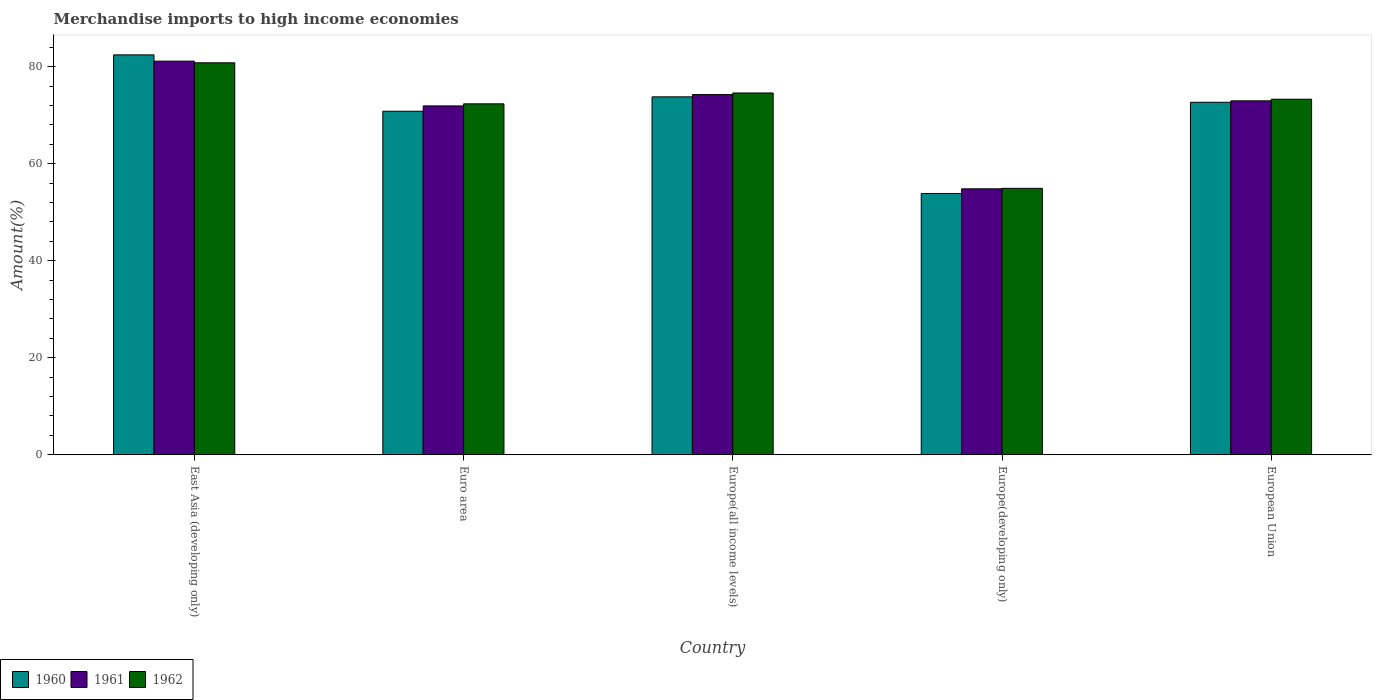How many different coloured bars are there?
Offer a very short reply. 3. How many groups of bars are there?
Provide a short and direct response. 5. Are the number of bars per tick equal to the number of legend labels?
Give a very brief answer. Yes. Are the number of bars on each tick of the X-axis equal?
Ensure brevity in your answer.  Yes. What is the label of the 3rd group of bars from the left?
Give a very brief answer. Europe(all income levels). In how many cases, is the number of bars for a given country not equal to the number of legend labels?
Give a very brief answer. 0. What is the percentage of amount earned from merchandise imports in 1962 in Europe(all income levels)?
Your response must be concise. 74.58. Across all countries, what is the maximum percentage of amount earned from merchandise imports in 1960?
Provide a short and direct response. 82.44. Across all countries, what is the minimum percentage of amount earned from merchandise imports in 1961?
Your answer should be very brief. 54.82. In which country was the percentage of amount earned from merchandise imports in 1960 maximum?
Offer a very short reply. East Asia (developing only). In which country was the percentage of amount earned from merchandise imports in 1960 minimum?
Your answer should be very brief. Europe(developing only). What is the total percentage of amount earned from merchandise imports in 1961 in the graph?
Make the answer very short. 355.09. What is the difference between the percentage of amount earned from merchandise imports in 1961 in Europe(developing only) and that in European Union?
Provide a short and direct response. -18.14. What is the difference between the percentage of amount earned from merchandise imports in 1961 in Europe(all income levels) and the percentage of amount earned from merchandise imports in 1962 in East Asia (developing only)?
Your answer should be very brief. -6.55. What is the average percentage of amount earned from merchandise imports in 1960 per country?
Your response must be concise. 70.71. What is the difference between the percentage of amount earned from merchandise imports of/in 1961 and percentage of amount earned from merchandise imports of/in 1960 in East Asia (developing only)?
Provide a succinct answer. -1.29. What is the ratio of the percentage of amount earned from merchandise imports in 1962 in Europe(all income levels) to that in European Union?
Your answer should be compact. 1.02. Is the difference between the percentage of amount earned from merchandise imports in 1961 in East Asia (developing only) and European Union greater than the difference between the percentage of amount earned from merchandise imports in 1960 in East Asia (developing only) and European Union?
Keep it short and to the point. No. What is the difference between the highest and the second highest percentage of amount earned from merchandise imports in 1962?
Offer a very short reply. 7.51. What is the difference between the highest and the lowest percentage of amount earned from merchandise imports in 1960?
Make the answer very short. 28.57. What does the 1st bar from the right in European Union represents?
Provide a short and direct response. 1962. Are all the bars in the graph horizontal?
Give a very brief answer. No. What is the difference between two consecutive major ticks on the Y-axis?
Your answer should be very brief. 20. Does the graph contain grids?
Keep it short and to the point. No. Where does the legend appear in the graph?
Keep it short and to the point. Bottom left. How many legend labels are there?
Offer a terse response. 3. How are the legend labels stacked?
Offer a terse response. Horizontal. What is the title of the graph?
Provide a succinct answer. Merchandise imports to high income economies. Does "1974" appear as one of the legend labels in the graph?
Your answer should be compact. No. What is the label or title of the Y-axis?
Provide a succinct answer. Amount(%). What is the Amount(%) in 1960 in East Asia (developing only)?
Keep it short and to the point. 82.44. What is the Amount(%) of 1961 in East Asia (developing only)?
Offer a very short reply. 81.14. What is the Amount(%) in 1962 in East Asia (developing only)?
Provide a succinct answer. 80.8. What is the Amount(%) in 1960 in Euro area?
Make the answer very short. 70.81. What is the Amount(%) in 1961 in Euro area?
Your answer should be very brief. 71.91. What is the Amount(%) in 1962 in Euro area?
Your answer should be compact. 72.34. What is the Amount(%) of 1960 in Europe(all income levels)?
Provide a succinct answer. 73.78. What is the Amount(%) in 1961 in Europe(all income levels)?
Your answer should be compact. 74.25. What is the Amount(%) in 1962 in Europe(all income levels)?
Ensure brevity in your answer.  74.58. What is the Amount(%) of 1960 in Europe(developing only)?
Ensure brevity in your answer.  53.86. What is the Amount(%) of 1961 in Europe(developing only)?
Offer a very short reply. 54.82. What is the Amount(%) of 1962 in Europe(developing only)?
Offer a very short reply. 54.93. What is the Amount(%) in 1960 in European Union?
Offer a very short reply. 72.67. What is the Amount(%) of 1961 in European Union?
Provide a succinct answer. 72.96. What is the Amount(%) of 1962 in European Union?
Offer a terse response. 73.29. Across all countries, what is the maximum Amount(%) in 1960?
Ensure brevity in your answer.  82.44. Across all countries, what is the maximum Amount(%) of 1961?
Your answer should be very brief. 81.14. Across all countries, what is the maximum Amount(%) of 1962?
Give a very brief answer. 80.8. Across all countries, what is the minimum Amount(%) of 1960?
Ensure brevity in your answer.  53.86. Across all countries, what is the minimum Amount(%) of 1961?
Your answer should be compact. 54.82. Across all countries, what is the minimum Amount(%) in 1962?
Ensure brevity in your answer.  54.93. What is the total Amount(%) in 1960 in the graph?
Provide a short and direct response. 353.56. What is the total Amount(%) in 1961 in the graph?
Your answer should be compact. 355.09. What is the total Amount(%) in 1962 in the graph?
Provide a succinct answer. 355.94. What is the difference between the Amount(%) in 1960 in East Asia (developing only) and that in Euro area?
Offer a terse response. 11.62. What is the difference between the Amount(%) of 1961 in East Asia (developing only) and that in Euro area?
Your response must be concise. 9.23. What is the difference between the Amount(%) of 1962 in East Asia (developing only) and that in Euro area?
Provide a succinct answer. 8.46. What is the difference between the Amount(%) of 1960 in East Asia (developing only) and that in Europe(all income levels)?
Make the answer very short. 8.65. What is the difference between the Amount(%) in 1961 in East Asia (developing only) and that in Europe(all income levels)?
Give a very brief answer. 6.89. What is the difference between the Amount(%) of 1962 in East Asia (developing only) and that in Europe(all income levels)?
Offer a very short reply. 6.22. What is the difference between the Amount(%) of 1960 in East Asia (developing only) and that in Europe(developing only)?
Offer a terse response. 28.57. What is the difference between the Amount(%) of 1961 in East Asia (developing only) and that in Europe(developing only)?
Ensure brevity in your answer.  26.32. What is the difference between the Amount(%) of 1962 in East Asia (developing only) and that in Europe(developing only)?
Give a very brief answer. 25.88. What is the difference between the Amount(%) of 1960 in East Asia (developing only) and that in European Union?
Make the answer very short. 9.77. What is the difference between the Amount(%) of 1961 in East Asia (developing only) and that in European Union?
Ensure brevity in your answer.  8.18. What is the difference between the Amount(%) in 1962 in East Asia (developing only) and that in European Union?
Provide a short and direct response. 7.51. What is the difference between the Amount(%) of 1960 in Euro area and that in Europe(all income levels)?
Your answer should be compact. -2.97. What is the difference between the Amount(%) of 1961 in Euro area and that in Europe(all income levels)?
Keep it short and to the point. -2.33. What is the difference between the Amount(%) in 1962 in Euro area and that in Europe(all income levels)?
Provide a short and direct response. -2.24. What is the difference between the Amount(%) in 1960 in Euro area and that in Europe(developing only)?
Keep it short and to the point. 16.95. What is the difference between the Amount(%) in 1961 in Euro area and that in Europe(developing only)?
Give a very brief answer. 17.09. What is the difference between the Amount(%) of 1962 in Euro area and that in Europe(developing only)?
Provide a short and direct response. 17.42. What is the difference between the Amount(%) of 1960 in Euro area and that in European Union?
Offer a terse response. -1.85. What is the difference between the Amount(%) in 1961 in Euro area and that in European Union?
Your answer should be very brief. -1.05. What is the difference between the Amount(%) in 1962 in Euro area and that in European Union?
Keep it short and to the point. -0.95. What is the difference between the Amount(%) of 1960 in Europe(all income levels) and that in Europe(developing only)?
Your response must be concise. 19.92. What is the difference between the Amount(%) in 1961 in Europe(all income levels) and that in Europe(developing only)?
Give a very brief answer. 19.42. What is the difference between the Amount(%) of 1962 in Europe(all income levels) and that in Europe(developing only)?
Provide a short and direct response. 19.66. What is the difference between the Amount(%) in 1960 in Europe(all income levels) and that in European Union?
Make the answer very short. 1.12. What is the difference between the Amount(%) of 1961 in Europe(all income levels) and that in European Union?
Give a very brief answer. 1.29. What is the difference between the Amount(%) in 1962 in Europe(all income levels) and that in European Union?
Your answer should be compact. 1.29. What is the difference between the Amount(%) of 1960 in Europe(developing only) and that in European Union?
Keep it short and to the point. -18.8. What is the difference between the Amount(%) of 1961 in Europe(developing only) and that in European Union?
Give a very brief answer. -18.14. What is the difference between the Amount(%) of 1962 in Europe(developing only) and that in European Union?
Provide a short and direct response. -18.37. What is the difference between the Amount(%) in 1960 in East Asia (developing only) and the Amount(%) in 1961 in Euro area?
Ensure brevity in your answer.  10.52. What is the difference between the Amount(%) of 1960 in East Asia (developing only) and the Amount(%) of 1962 in Euro area?
Provide a succinct answer. 10.09. What is the difference between the Amount(%) of 1961 in East Asia (developing only) and the Amount(%) of 1962 in Euro area?
Your response must be concise. 8.8. What is the difference between the Amount(%) of 1960 in East Asia (developing only) and the Amount(%) of 1961 in Europe(all income levels)?
Ensure brevity in your answer.  8.19. What is the difference between the Amount(%) of 1960 in East Asia (developing only) and the Amount(%) of 1962 in Europe(all income levels)?
Provide a succinct answer. 7.85. What is the difference between the Amount(%) of 1961 in East Asia (developing only) and the Amount(%) of 1962 in Europe(all income levels)?
Keep it short and to the point. 6.56. What is the difference between the Amount(%) of 1960 in East Asia (developing only) and the Amount(%) of 1961 in Europe(developing only)?
Your response must be concise. 27.61. What is the difference between the Amount(%) of 1960 in East Asia (developing only) and the Amount(%) of 1962 in Europe(developing only)?
Your answer should be very brief. 27.51. What is the difference between the Amount(%) of 1961 in East Asia (developing only) and the Amount(%) of 1962 in Europe(developing only)?
Keep it short and to the point. 26.22. What is the difference between the Amount(%) of 1960 in East Asia (developing only) and the Amount(%) of 1961 in European Union?
Offer a terse response. 9.48. What is the difference between the Amount(%) in 1960 in East Asia (developing only) and the Amount(%) in 1962 in European Union?
Your answer should be very brief. 9.14. What is the difference between the Amount(%) of 1961 in East Asia (developing only) and the Amount(%) of 1962 in European Union?
Offer a very short reply. 7.85. What is the difference between the Amount(%) in 1960 in Euro area and the Amount(%) in 1961 in Europe(all income levels)?
Your answer should be very brief. -3.43. What is the difference between the Amount(%) in 1960 in Euro area and the Amount(%) in 1962 in Europe(all income levels)?
Your response must be concise. -3.77. What is the difference between the Amount(%) in 1961 in Euro area and the Amount(%) in 1962 in Europe(all income levels)?
Offer a terse response. -2.67. What is the difference between the Amount(%) in 1960 in Euro area and the Amount(%) in 1961 in Europe(developing only)?
Keep it short and to the point. 15.99. What is the difference between the Amount(%) in 1960 in Euro area and the Amount(%) in 1962 in Europe(developing only)?
Your answer should be very brief. 15.89. What is the difference between the Amount(%) of 1961 in Euro area and the Amount(%) of 1962 in Europe(developing only)?
Your answer should be very brief. 16.99. What is the difference between the Amount(%) of 1960 in Euro area and the Amount(%) of 1961 in European Union?
Your answer should be very brief. -2.14. What is the difference between the Amount(%) of 1960 in Euro area and the Amount(%) of 1962 in European Union?
Your answer should be compact. -2.48. What is the difference between the Amount(%) of 1961 in Euro area and the Amount(%) of 1962 in European Union?
Keep it short and to the point. -1.38. What is the difference between the Amount(%) of 1960 in Europe(all income levels) and the Amount(%) of 1961 in Europe(developing only)?
Keep it short and to the point. 18.96. What is the difference between the Amount(%) of 1960 in Europe(all income levels) and the Amount(%) of 1962 in Europe(developing only)?
Provide a succinct answer. 18.86. What is the difference between the Amount(%) in 1961 in Europe(all income levels) and the Amount(%) in 1962 in Europe(developing only)?
Your response must be concise. 19.32. What is the difference between the Amount(%) in 1960 in Europe(all income levels) and the Amount(%) in 1961 in European Union?
Your answer should be very brief. 0.82. What is the difference between the Amount(%) of 1960 in Europe(all income levels) and the Amount(%) of 1962 in European Union?
Ensure brevity in your answer.  0.49. What is the difference between the Amount(%) of 1961 in Europe(all income levels) and the Amount(%) of 1962 in European Union?
Offer a terse response. 0.96. What is the difference between the Amount(%) of 1960 in Europe(developing only) and the Amount(%) of 1961 in European Union?
Give a very brief answer. -19.09. What is the difference between the Amount(%) of 1960 in Europe(developing only) and the Amount(%) of 1962 in European Union?
Provide a succinct answer. -19.43. What is the difference between the Amount(%) in 1961 in Europe(developing only) and the Amount(%) in 1962 in European Union?
Offer a very short reply. -18.47. What is the average Amount(%) of 1960 per country?
Your response must be concise. 70.71. What is the average Amount(%) in 1961 per country?
Provide a succinct answer. 71.02. What is the average Amount(%) in 1962 per country?
Your response must be concise. 71.19. What is the difference between the Amount(%) of 1960 and Amount(%) of 1961 in East Asia (developing only)?
Your answer should be very brief. 1.29. What is the difference between the Amount(%) of 1960 and Amount(%) of 1962 in East Asia (developing only)?
Offer a very short reply. 1.63. What is the difference between the Amount(%) in 1961 and Amount(%) in 1962 in East Asia (developing only)?
Keep it short and to the point. 0.34. What is the difference between the Amount(%) in 1960 and Amount(%) in 1961 in Euro area?
Provide a succinct answer. -1.1. What is the difference between the Amount(%) in 1960 and Amount(%) in 1962 in Euro area?
Your answer should be very brief. -1.53. What is the difference between the Amount(%) in 1961 and Amount(%) in 1962 in Euro area?
Offer a terse response. -0.43. What is the difference between the Amount(%) in 1960 and Amount(%) in 1961 in Europe(all income levels)?
Offer a terse response. -0.47. What is the difference between the Amount(%) of 1960 and Amount(%) of 1962 in Europe(all income levels)?
Provide a short and direct response. -0.8. What is the difference between the Amount(%) in 1961 and Amount(%) in 1962 in Europe(all income levels)?
Keep it short and to the point. -0.33. What is the difference between the Amount(%) in 1960 and Amount(%) in 1961 in Europe(developing only)?
Offer a terse response. -0.96. What is the difference between the Amount(%) in 1960 and Amount(%) in 1962 in Europe(developing only)?
Give a very brief answer. -1.06. What is the difference between the Amount(%) of 1961 and Amount(%) of 1962 in Europe(developing only)?
Your answer should be very brief. -0.1. What is the difference between the Amount(%) in 1960 and Amount(%) in 1961 in European Union?
Give a very brief answer. -0.29. What is the difference between the Amount(%) in 1960 and Amount(%) in 1962 in European Union?
Provide a short and direct response. -0.63. What is the difference between the Amount(%) of 1961 and Amount(%) of 1962 in European Union?
Keep it short and to the point. -0.33. What is the ratio of the Amount(%) of 1960 in East Asia (developing only) to that in Euro area?
Offer a terse response. 1.16. What is the ratio of the Amount(%) of 1961 in East Asia (developing only) to that in Euro area?
Ensure brevity in your answer.  1.13. What is the ratio of the Amount(%) in 1962 in East Asia (developing only) to that in Euro area?
Make the answer very short. 1.12. What is the ratio of the Amount(%) in 1960 in East Asia (developing only) to that in Europe(all income levels)?
Give a very brief answer. 1.12. What is the ratio of the Amount(%) in 1961 in East Asia (developing only) to that in Europe(all income levels)?
Offer a terse response. 1.09. What is the ratio of the Amount(%) in 1962 in East Asia (developing only) to that in Europe(all income levels)?
Offer a very short reply. 1.08. What is the ratio of the Amount(%) in 1960 in East Asia (developing only) to that in Europe(developing only)?
Provide a succinct answer. 1.53. What is the ratio of the Amount(%) in 1961 in East Asia (developing only) to that in Europe(developing only)?
Ensure brevity in your answer.  1.48. What is the ratio of the Amount(%) of 1962 in East Asia (developing only) to that in Europe(developing only)?
Your answer should be compact. 1.47. What is the ratio of the Amount(%) of 1960 in East Asia (developing only) to that in European Union?
Your response must be concise. 1.13. What is the ratio of the Amount(%) in 1961 in East Asia (developing only) to that in European Union?
Make the answer very short. 1.11. What is the ratio of the Amount(%) in 1962 in East Asia (developing only) to that in European Union?
Ensure brevity in your answer.  1.1. What is the ratio of the Amount(%) of 1960 in Euro area to that in Europe(all income levels)?
Keep it short and to the point. 0.96. What is the ratio of the Amount(%) in 1961 in Euro area to that in Europe(all income levels)?
Ensure brevity in your answer.  0.97. What is the ratio of the Amount(%) of 1960 in Euro area to that in Europe(developing only)?
Offer a terse response. 1.31. What is the ratio of the Amount(%) of 1961 in Euro area to that in Europe(developing only)?
Offer a very short reply. 1.31. What is the ratio of the Amount(%) in 1962 in Euro area to that in Europe(developing only)?
Give a very brief answer. 1.32. What is the ratio of the Amount(%) in 1960 in Euro area to that in European Union?
Offer a very short reply. 0.97. What is the ratio of the Amount(%) of 1961 in Euro area to that in European Union?
Make the answer very short. 0.99. What is the ratio of the Amount(%) in 1962 in Euro area to that in European Union?
Ensure brevity in your answer.  0.99. What is the ratio of the Amount(%) in 1960 in Europe(all income levels) to that in Europe(developing only)?
Your response must be concise. 1.37. What is the ratio of the Amount(%) of 1961 in Europe(all income levels) to that in Europe(developing only)?
Offer a very short reply. 1.35. What is the ratio of the Amount(%) in 1962 in Europe(all income levels) to that in Europe(developing only)?
Your answer should be compact. 1.36. What is the ratio of the Amount(%) in 1960 in Europe(all income levels) to that in European Union?
Make the answer very short. 1.02. What is the ratio of the Amount(%) in 1961 in Europe(all income levels) to that in European Union?
Provide a short and direct response. 1.02. What is the ratio of the Amount(%) of 1962 in Europe(all income levels) to that in European Union?
Offer a terse response. 1.02. What is the ratio of the Amount(%) of 1960 in Europe(developing only) to that in European Union?
Provide a succinct answer. 0.74. What is the ratio of the Amount(%) in 1961 in Europe(developing only) to that in European Union?
Your answer should be compact. 0.75. What is the ratio of the Amount(%) of 1962 in Europe(developing only) to that in European Union?
Give a very brief answer. 0.75. What is the difference between the highest and the second highest Amount(%) in 1960?
Ensure brevity in your answer.  8.65. What is the difference between the highest and the second highest Amount(%) of 1961?
Your response must be concise. 6.89. What is the difference between the highest and the second highest Amount(%) of 1962?
Your answer should be very brief. 6.22. What is the difference between the highest and the lowest Amount(%) of 1960?
Your answer should be very brief. 28.57. What is the difference between the highest and the lowest Amount(%) of 1961?
Provide a short and direct response. 26.32. What is the difference between the highest and the lowest Amount(%) of 1962?
Your answer should be very brief. 25.88. 